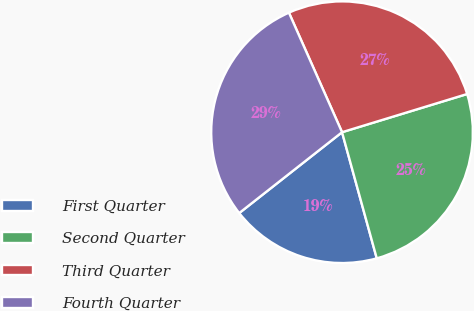<chart> <loc_0><loc_0><loc_500><loc_500><pie_chart><fcel>First Quarter<fcel>Second Quarter<fcel>Third Quarter<fcel>Fourth Quarter<nl><fcel>18.67%<fcel>25.44%<fcel>26.94%<fcel>28.95%<nl></chart> 